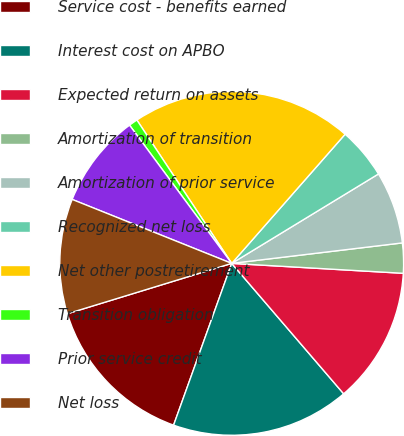Convert chart. <chart><loc_0><loc_0><loc_500><loc_500><pie_chart><fcel>Service cost - benefits earned<fcel>Interest cost on APBO<fcel>Expected return on assets<fcel>Amortization of transition<fcel>Amortization of prior service<fcel>Recognized net loss<fcel>Net other postretirement<fcel>Transition obligation<fcel>Prior service credit<fcel>Net loss<nl><fcel>14.78%<fcel>16.78%<fcel>12.79%<fcel>2.82%<fcel>6.81%<fcel>4.82%<fcel>20.77%<fcel>0.83%<fcel>8.8%<fcel>10.8%<nl></chart> 